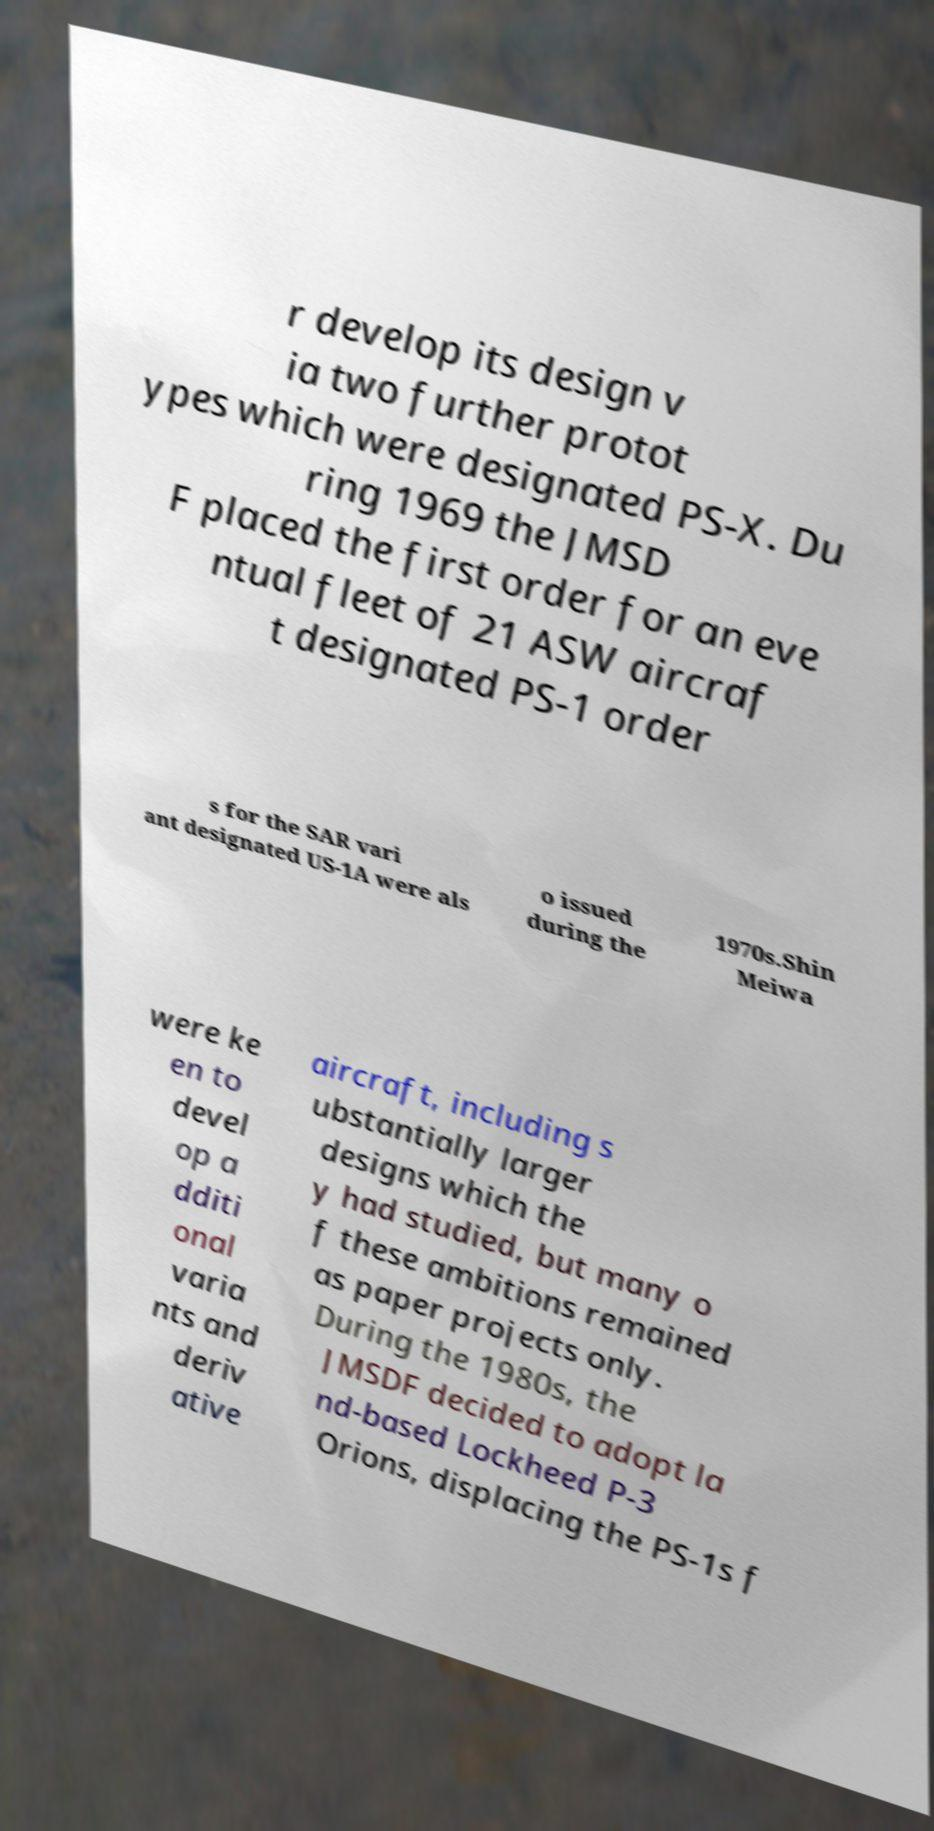Please identify and transcribe the text found in this image. r develop its design v ia two further protot ypes which were designated PS-X. Du ring 1969 the JMSD F placed the first order for an eve ntual fleet of 21 ASW aircraf t designated PS-1 order s for the SAR vari ant designated US-1A were als o issued during the 1970s.Shin Meiwa were ke en to devel op a dditi onal varia nts and deriv ative aircraft, including s ubstantially larger designs which the y had studied, but many o f these ambitions remained as paper projects only. During the 1980s, the JMSDF decided to adopt la nd-based Lockheed P-3 Orions, displacing the PS-1s f 